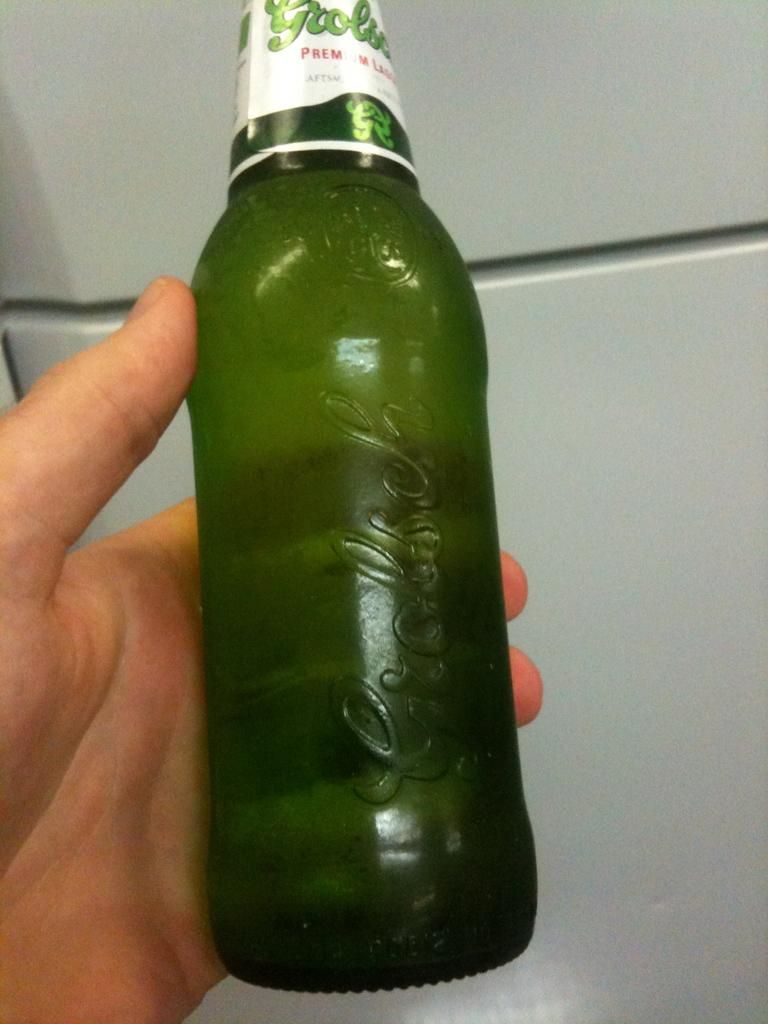What is the main subject of the image? There is a person in the image. What is the person holding in the image? The person is holding a green bottle. Can you describe the bottle in more detail? The bottle has a sticker on it, and the background of the bottle is a wall. How many crows are sitting on the person's shoulder in the image? There are no crows present in the image. Is there any dirt visible on the person's clothing in the image? The provided facts do not mention any dirt on the person's clothing, so we cannot determine its presence from the image. 